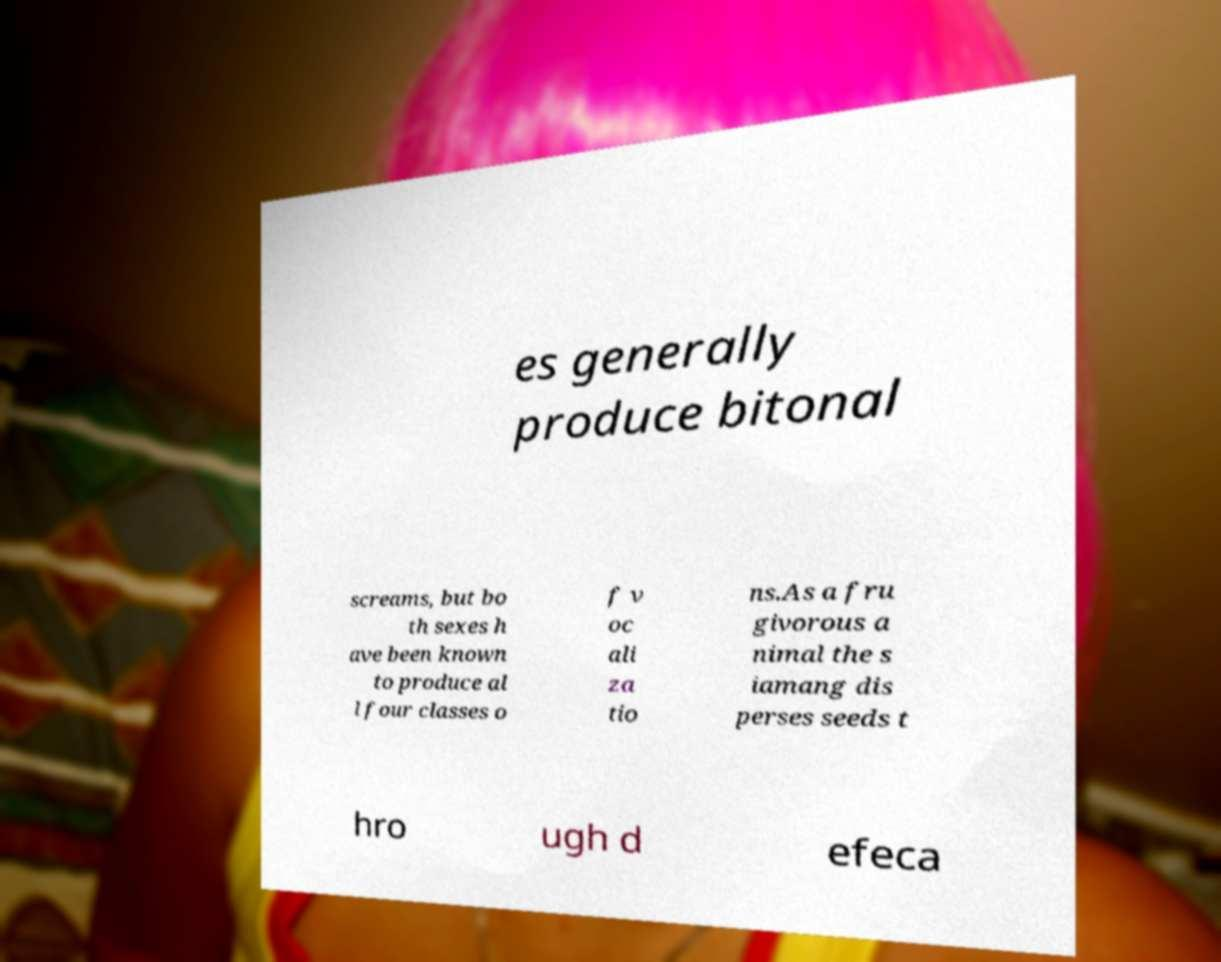Can you read and provide the text displayed in the image?This photo seems to have some interesting text. Can you extract and type it out for me? es generally produce bitonal screams, but bo th sexes h ave been known to produce al l four classes o f v oc ali za tio ns.As a fru givorous a nimal the s iamang dis perses seeds t hro ugh d efeca 